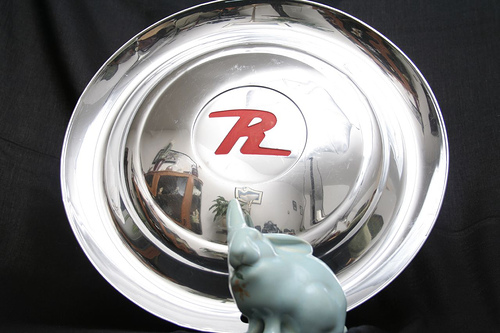<image>
Is there a picture in the disk? Yes. The picture is contained within or inside the disk, showing a containment relationship. 